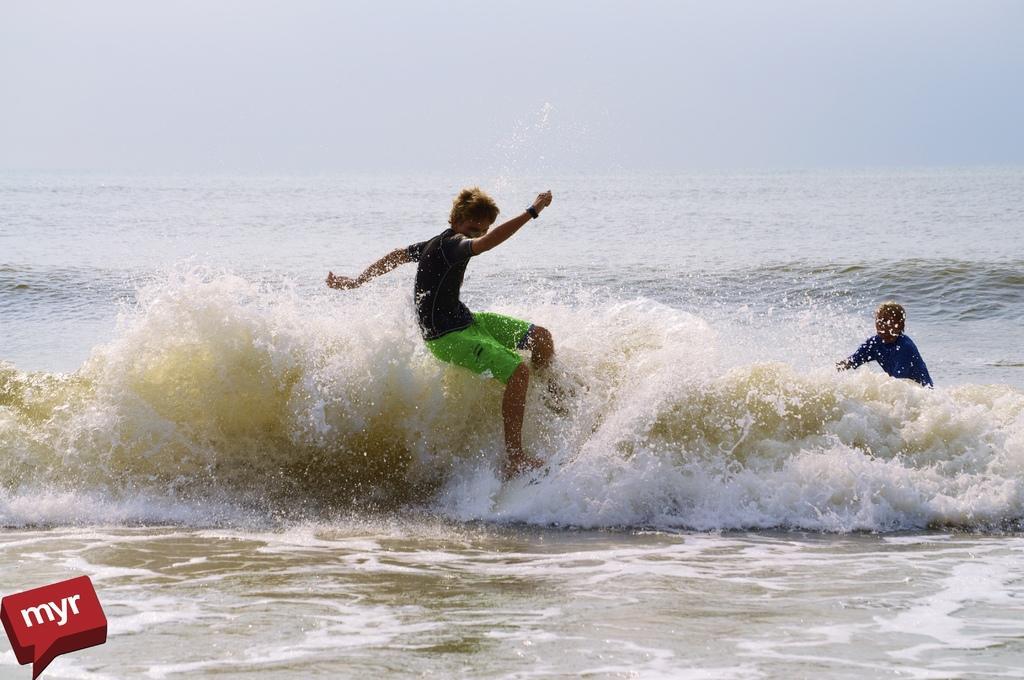Can you describe this image briefly? This image is taken outdoors. At the top of the image the is a sky. At the bottom of the image there is a sea with waves. In the middle of the image a boy is surfing on the sea with a surfing board and on the right side of the image there is another person surfing on the sea. 